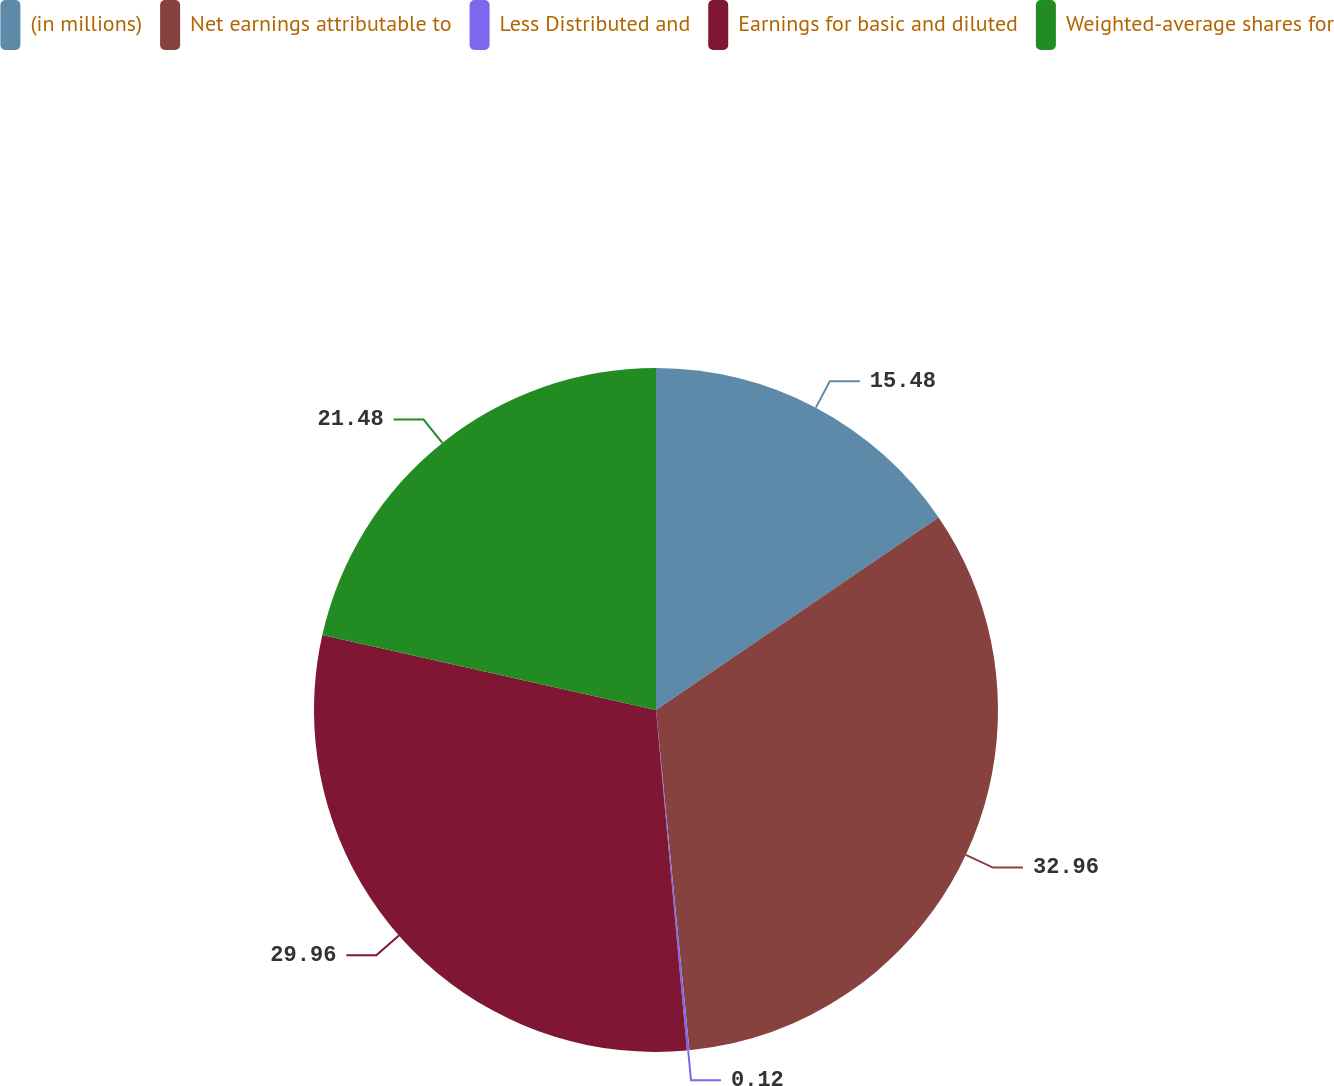Convert chart to OTSL. <chart><loc_0><loc_0><loc_500><loc_500><pie_chart><fcel>(in millions)<fcel>Net earnings attributable to<fcel>Less Distributed and<fcel>Earnings for basic and diluted<fcel>Weighted-average shares for<nl><fcel>15.48%<fcel>32.96%<fcel>0.12%<fcel>29.96%<fcel>21.48%<nl></chart> 